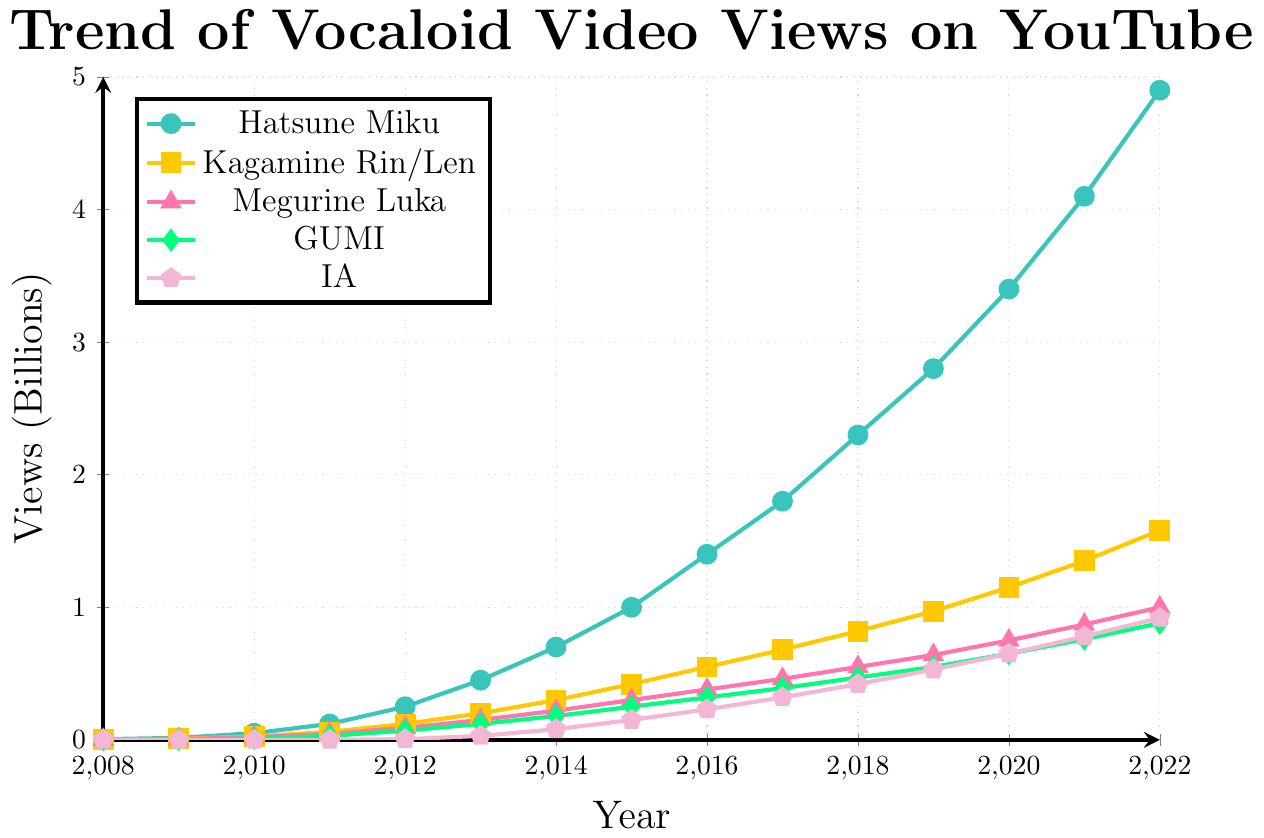What year did Hatsune Miku surpass 1 billion views? By examining the plot, Hatsune Miku surpassed 1 billion views in 2015, where the corresponding data point reaches the 1 billion mark.
Answer: 2015 Which Vocaloid character had the most significant increase in views between 2011 and 2012? The increases between 2011 and 2012 can be calculated by subtracting the 2011 value from the 2012 value for each character:
- Hatsune Miku: 250M - 120M = 130M
- Kagamine Rin/Len: 120M - 60M = 60M
- Megurine Luka: 90M - 45M = 45M
- GUMI: 70M - 30M = 40M
- IA: 5M - 0 = 5M
Hatsune Miku had the most significant increase of 130 million views.
Answer: Hatsune Miku What is the total number of views in 2014 for all characters combined? Summing up the views for all characters in 2014:
- Hatsune Miku: 700M
- Kagamine Rin/Len: 300M
- Megurine Luka: 220M
- GUMI: 180M
- IA: 80M
Total = 700 + 300 + 220 + 180 + 80 = 1480M = 1.48 billion
Answer: 1.48 billion Which Vocaloid character's view count reached half a billion first, and in what year? By examining the time series data:
- Hatsune Miku reached 500M between 2011 and 2012.
- Kagamine Rin/Len between 2014 and 2015.
- Megurine Luka between 2017 and 2018.
- GUMI has not reached 500M by 2022.
- IA between 2018 and 2019.
Therefore, Hatsune Miku reached 500M first in 2012.
Answer: Hatsune Miku, 2012 How does IA's growth in views from 2019 to 2022 compare with GUMI's growth in the same period? Calculating the growth:
- IA: 920M in 2022 - 530M in 2019 = 390M
- GUMI: 880M in 2022 - 550M in 2019 = 330M
IA's growth of 390M is greater than GUMI's growth of 330M.
Answer: IA had more growth In which year did GUMI's views first surpass 0.4 billion? Checking the plot, GUMI surpassed 0.4 billion views by 2018.
Answer: 2018 From 2008 to 2022, which year saw the highest increase in views for Megurine Luka? By examining the increments year by year, the largest increment for Megurine Luka is:
- 2008-2009: 0.005 - 0.001 = 0.004 billion
- 2009-2010: 0.02 - 0.005 = 0.015 billion
- 2010-2011: 0.045 - 0.02 = 0.025 billion
- 2011-2012: 0.09 - 0.045 = 0.045 billion
- 2012-2013: 0.15 - 0.09 = 0.06 billion
- 2013-2014: 0.22 - 0.15 = 0.07 billion
- 2014-2015: 0.3 - 0.22 = 0.08 billion
- 2015-2016: 0.38 - 0.3 = 0.08 billion
- 2016-2017: 0.46 - 0.38 = 0.08 billion
- 2017-2018: 0.55 - 0.46 = 0.09 billion
- 2018-2019: 0.64 - 0.55 = 0.09 billion
- 2019-2020: 0.75 - 0.64 = 0.11 billion
- 2020-2021: 0.87 - 0.75 = 0.12 billion
- 2021-2022: 1.0 - 0.87 = 0.13 billion
Thus, the highest increase in 2021-2022 with 0.13 billion.
Answer: 2021-2022 